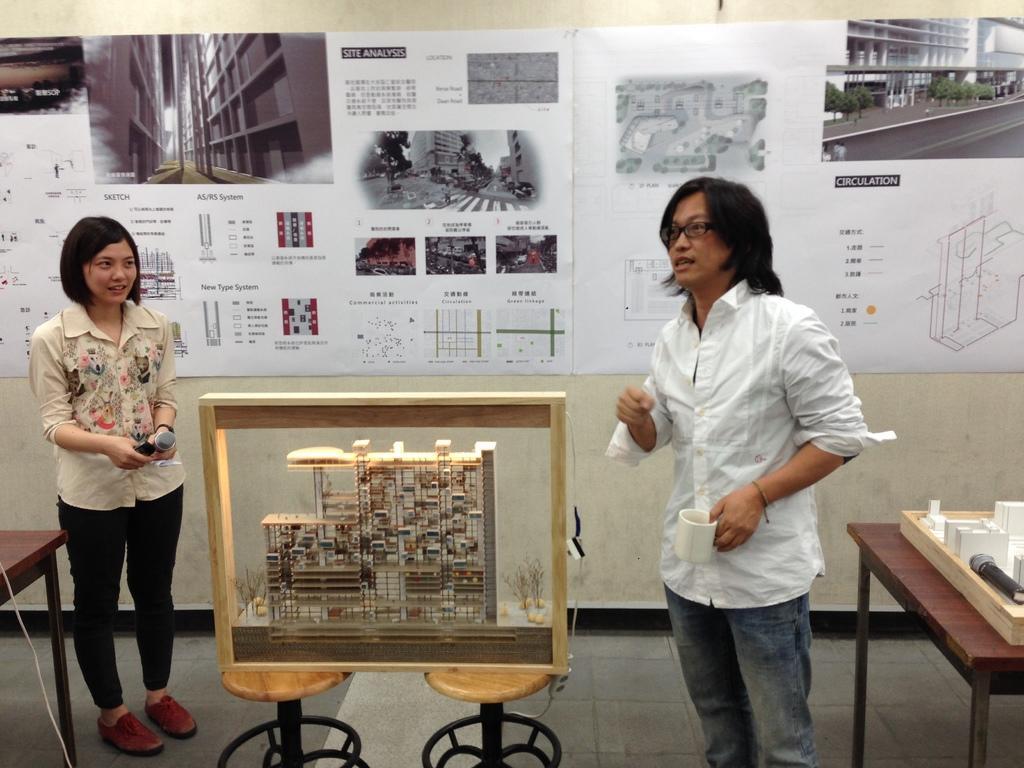Please provide a concise description of this image. On the background we can see posts over a wall. Here we can see a man holding a cup in his hand and a woman holding a mike in her hand. On the chairs we can see an engineers building plan. These are tables and on the table we can see a mule and a planning board. 